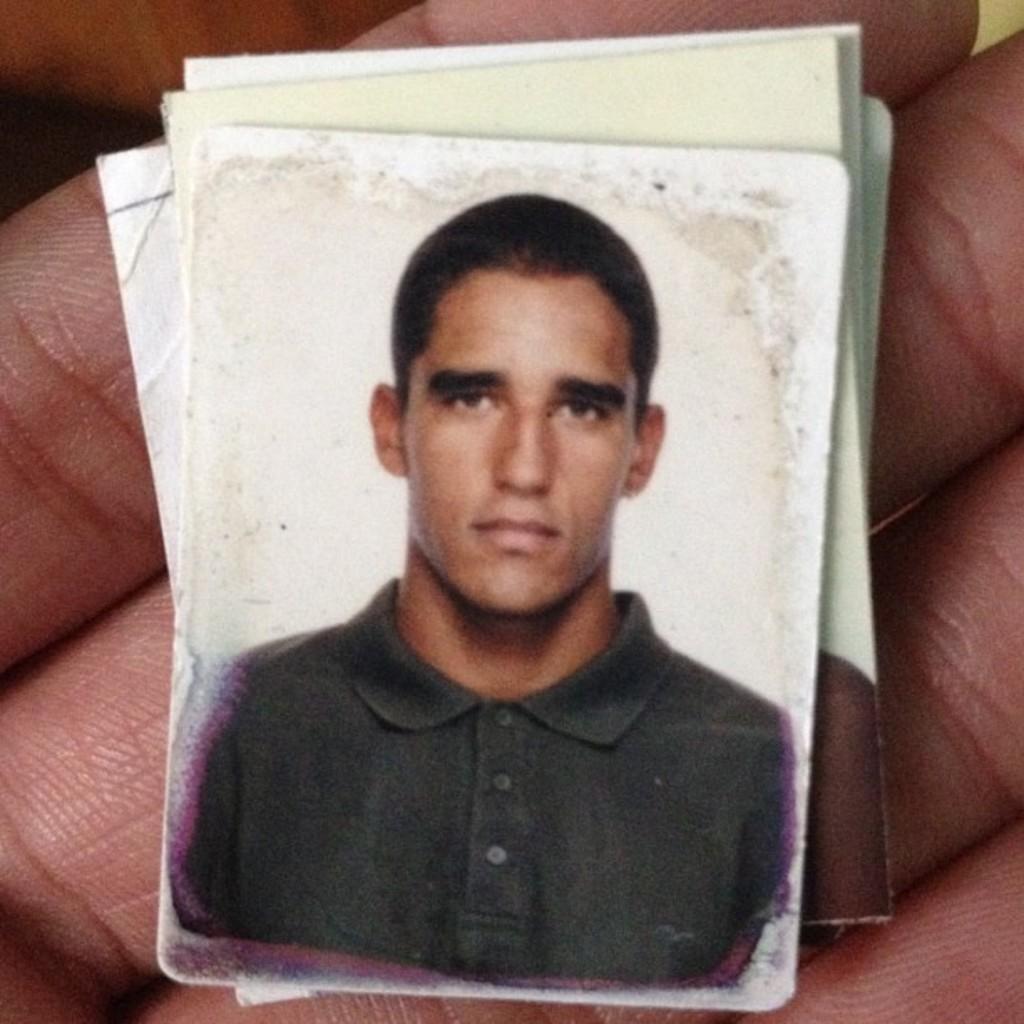How would you summarize this image in a sentence or two? In this picture I can see a person's fingers and on the fingers I can see a photograph of a man who is wearing t-shirt and I see few papers. 